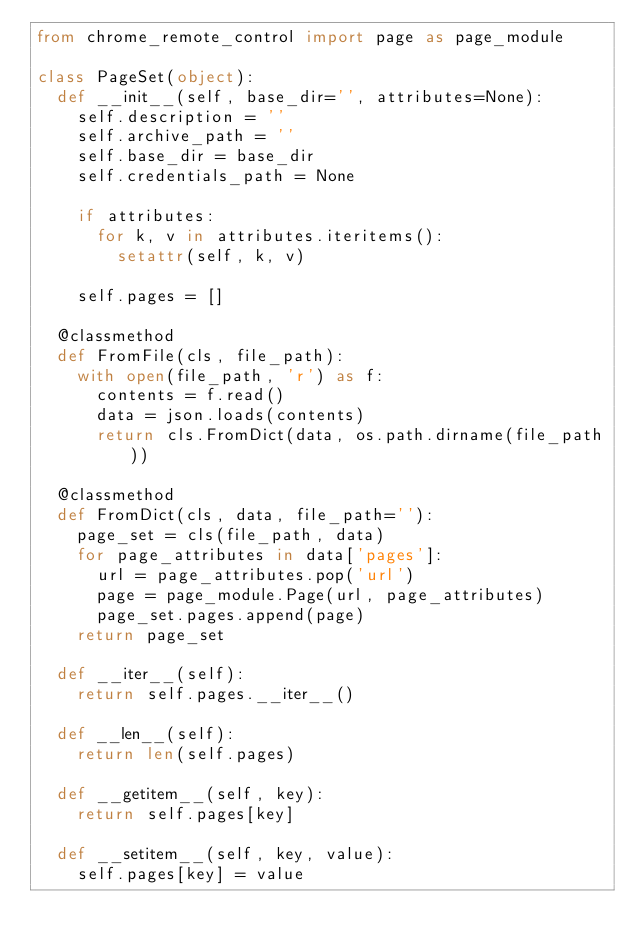Convert code to text. <code><loc_0><loc_0><loc_500><loc_500><_Python_>from chrome_remote_control import page as page_module

class PageSet(object):
  def __init__(self, base_dir='', attributes=None):
    self.description = ''
    self.archive_path = ''
    self.base_dir = base_dir
    self.credentials_path = None

    if attributes:
      for k, v in attributes.iteritems():
        setattr(self, k, v)

    self.pages = []

  @classmethod
  def FromFile(cls, file_path):
    with open(file_path, 'r') as f:
      contents = f.read()
      data = json.loads(contents)
      return cls.FromDict(data, os.path.dirname(file_path))

  @classmethod
  def FromDict(cls, data, file_path=''):
    page_set = cls(file_path, data)
    for page_attributes in data['pages']:
      url = page_attributes.pop('url')
      page = page_module.Page(url, page_attributes)
      page_set.pages.append(page)
    return page_set

  def __iter__(self):
    return self.pages.__iter__()

  def __len__(self):
    return len(self.pages)

  def __getitem__(self, key):
    return self.pages[key]

  def __setitem__(self, key, value):
    self.pages[key] = value
</code> 